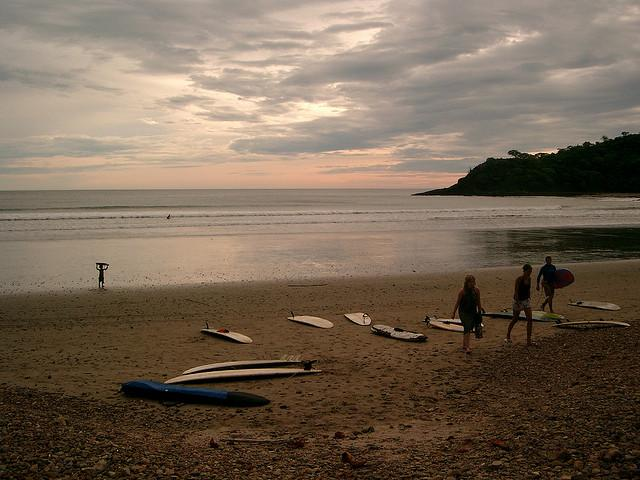Why is he carrying his surfboard? going surfing 